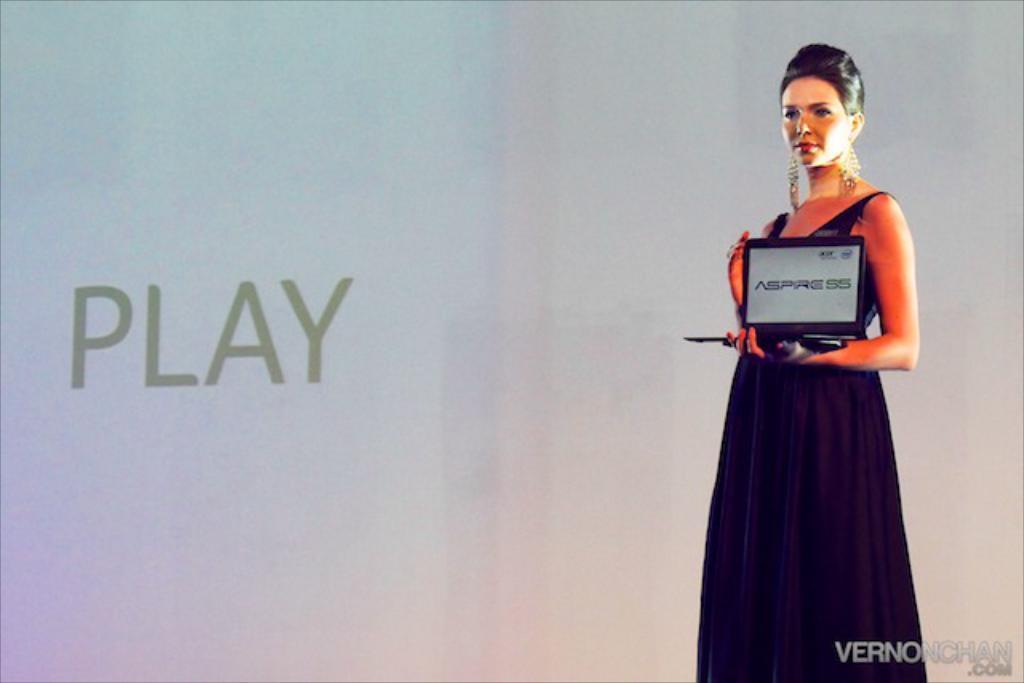In one or two sentences, can you explain what this image depicts? In this picture there is a woman with black dress is standing and holding the device and there is text on the screen. On the left side of the image there is text. At the bottom right there is text. 